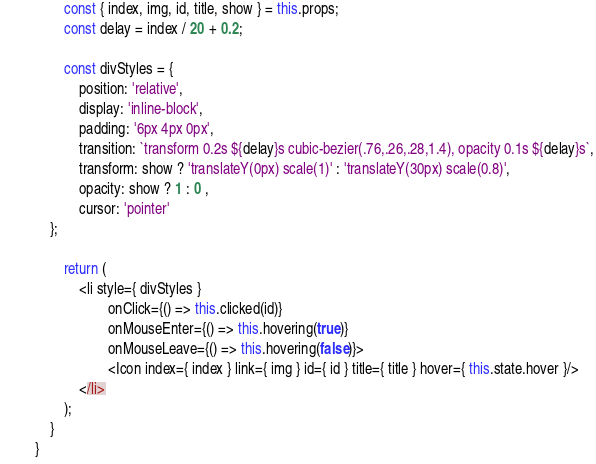Convert code to text. <code><loc_0><loc_0><loc_500><loc_500><_JavaScript_>
		const { index, img, id, title, show } = this.props;
		const delay = index / 20 + 0.2;

		const divStyles = {
			position: 'relative',
			display: 'inline-block',
			padding: '6px 4px 0px',
			transition: `transform 0.2s ${delay}s cubic-bezier(.76,.26,.28,1.4), opacity 0.1s ${delay}s`,
			transform: show ? 'translateY(0px) scale(1)' : 'translateY(30px) scale(0.8)',
			opacity: show ? 1 : 0 ,
			cursor: 'pointer'
  	};

		return (
			<li style={ divStyles } 
					onClick={() => this.clicked(id)}
					onMouseEnter={() => this.hovering(true)}
					onMouseLeave={() => this.hovering(false)}>
					<Icon index={ index } link={ img } id={ id } title={ title } hover={ this.state.hover }/> 
			</li>
		);
	}
}
</code> 